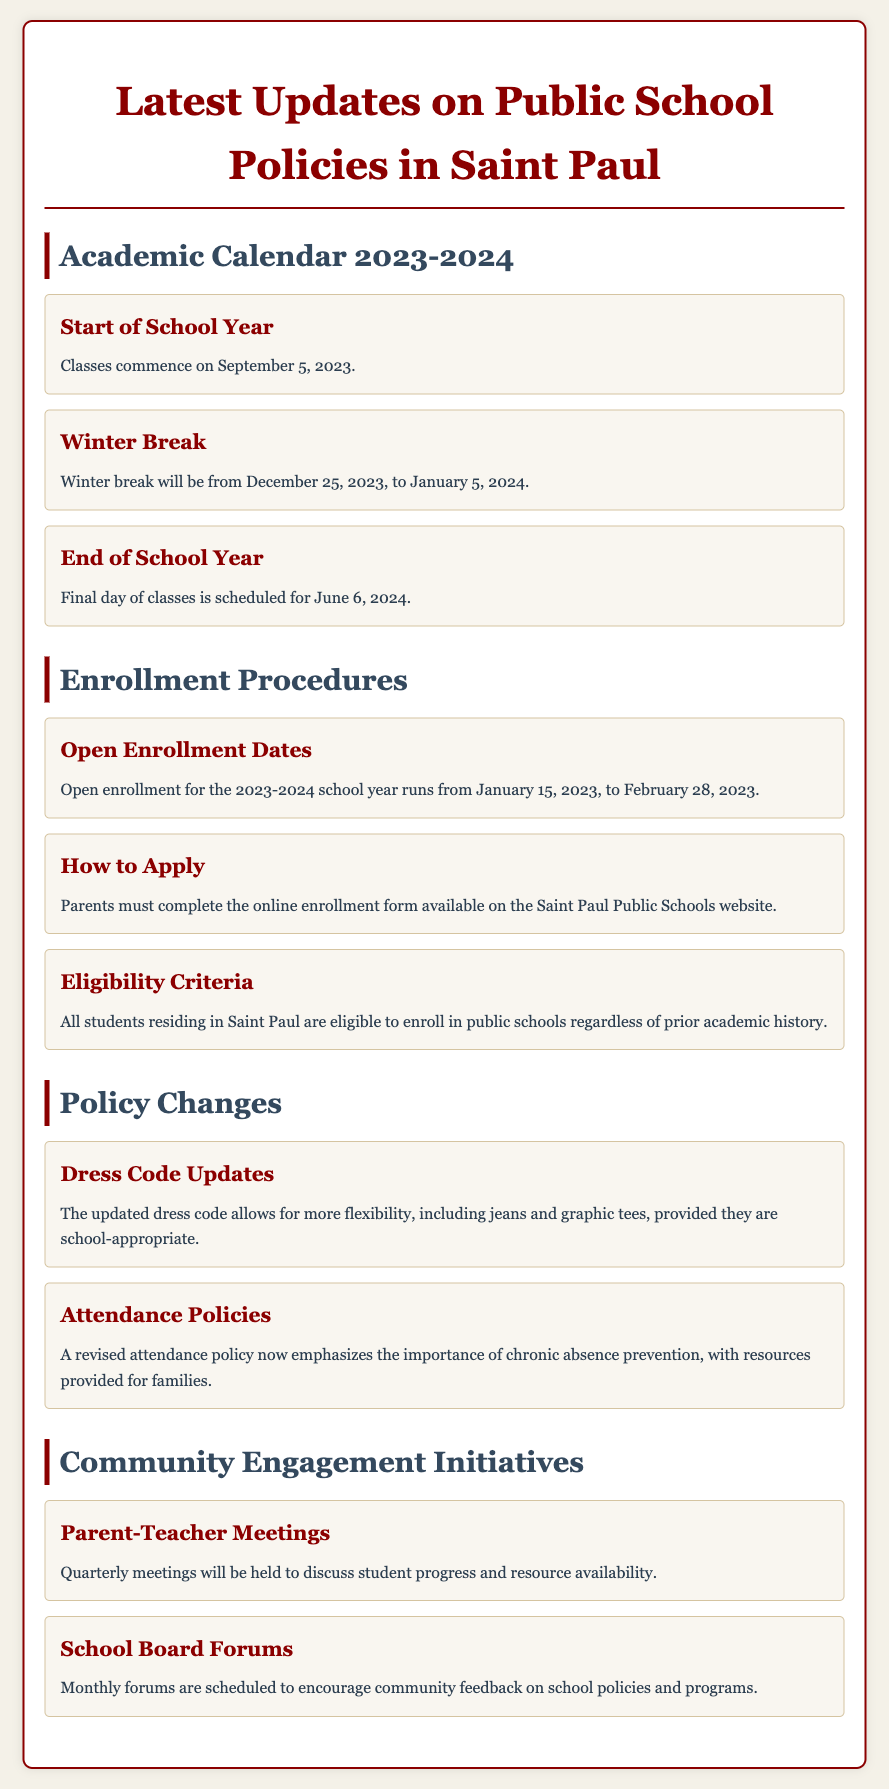What is the start date of the school year? The start date of the school year is mentioned in the Academic Calendar section and is September 5, 2023.
Answer: September 5, 2023 When is winter break scheduled? The winter break dates are provided in the Academic Calendar section. They span from December 25, 2023, to January 5, 2024.
Answer: December 25, 2023, to January 5, 2024 What are the open enrollment dates for 2023-2024? The open enrollment dates for the 2023-2024 school year are specifically outlined in the Enrollment Procedures section as January 15, 2023, to February 28, 2023.
Answer: January 15, 2023, to February 28, 2023 What updates were made to the dress code? The document mentions the updated dress code allows for more flexibility, including specific attire options that are appropriate for school.
Answer: More flexibility, including jeans and graphic tees How frequently will parent-teacher meetings be held? The frequency of the parent-teacher meetings is stated in the Community Engagement Initiatives section as quarterly.
Answer: Quarterly What is emphasized in the revised attendance policy? The revised attendance policy highlights the emphasis on chronic absence prevention along with provided resources.
Answer: Chronic absence prevention Who is eligible to enroll in the public schools? The eligibility criteria explained in the Enrollment Procedures section state that all students residing in Saint Paul are eligible regardless of prior academic history.
Answer: All students residing in Saint Paul What type of forums are scheduled monthly? The types of forums mentioned in the Community Engagement Initiatives section are specifically designed to encourage community feedback on school policies.
Answer: School Board Forums 